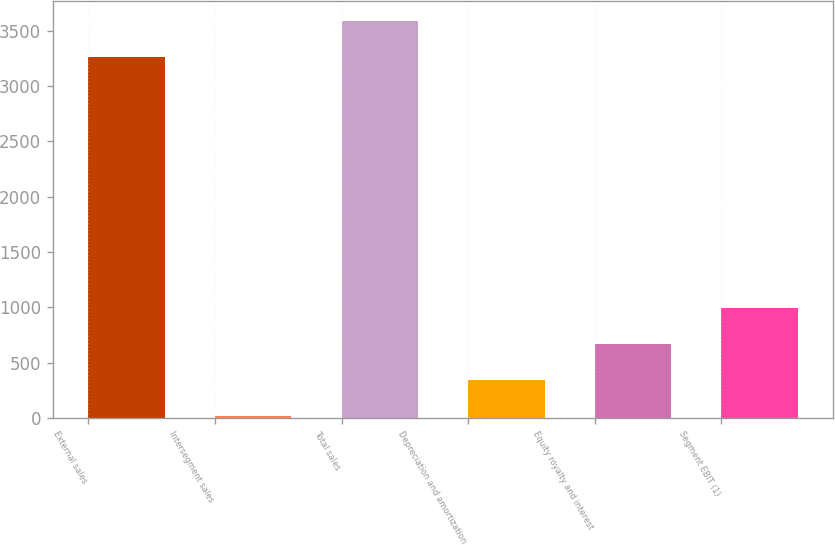Convert chart to OTSL. <chart><loc_0><loc_0><loc_500><loc_500><bar_chart><fcel>External sales<fcel>Intersegment sales<fcel>Total sales<fcel>Depreciation and amortization<fcel>Equity royalty and interest<fcel>Segment EBIT (1)<nl><fcel>3261<fcel>16<fcel>3587.1<fcel>342.1<fcel>668.2<fcel>994.3<nl></chart> 